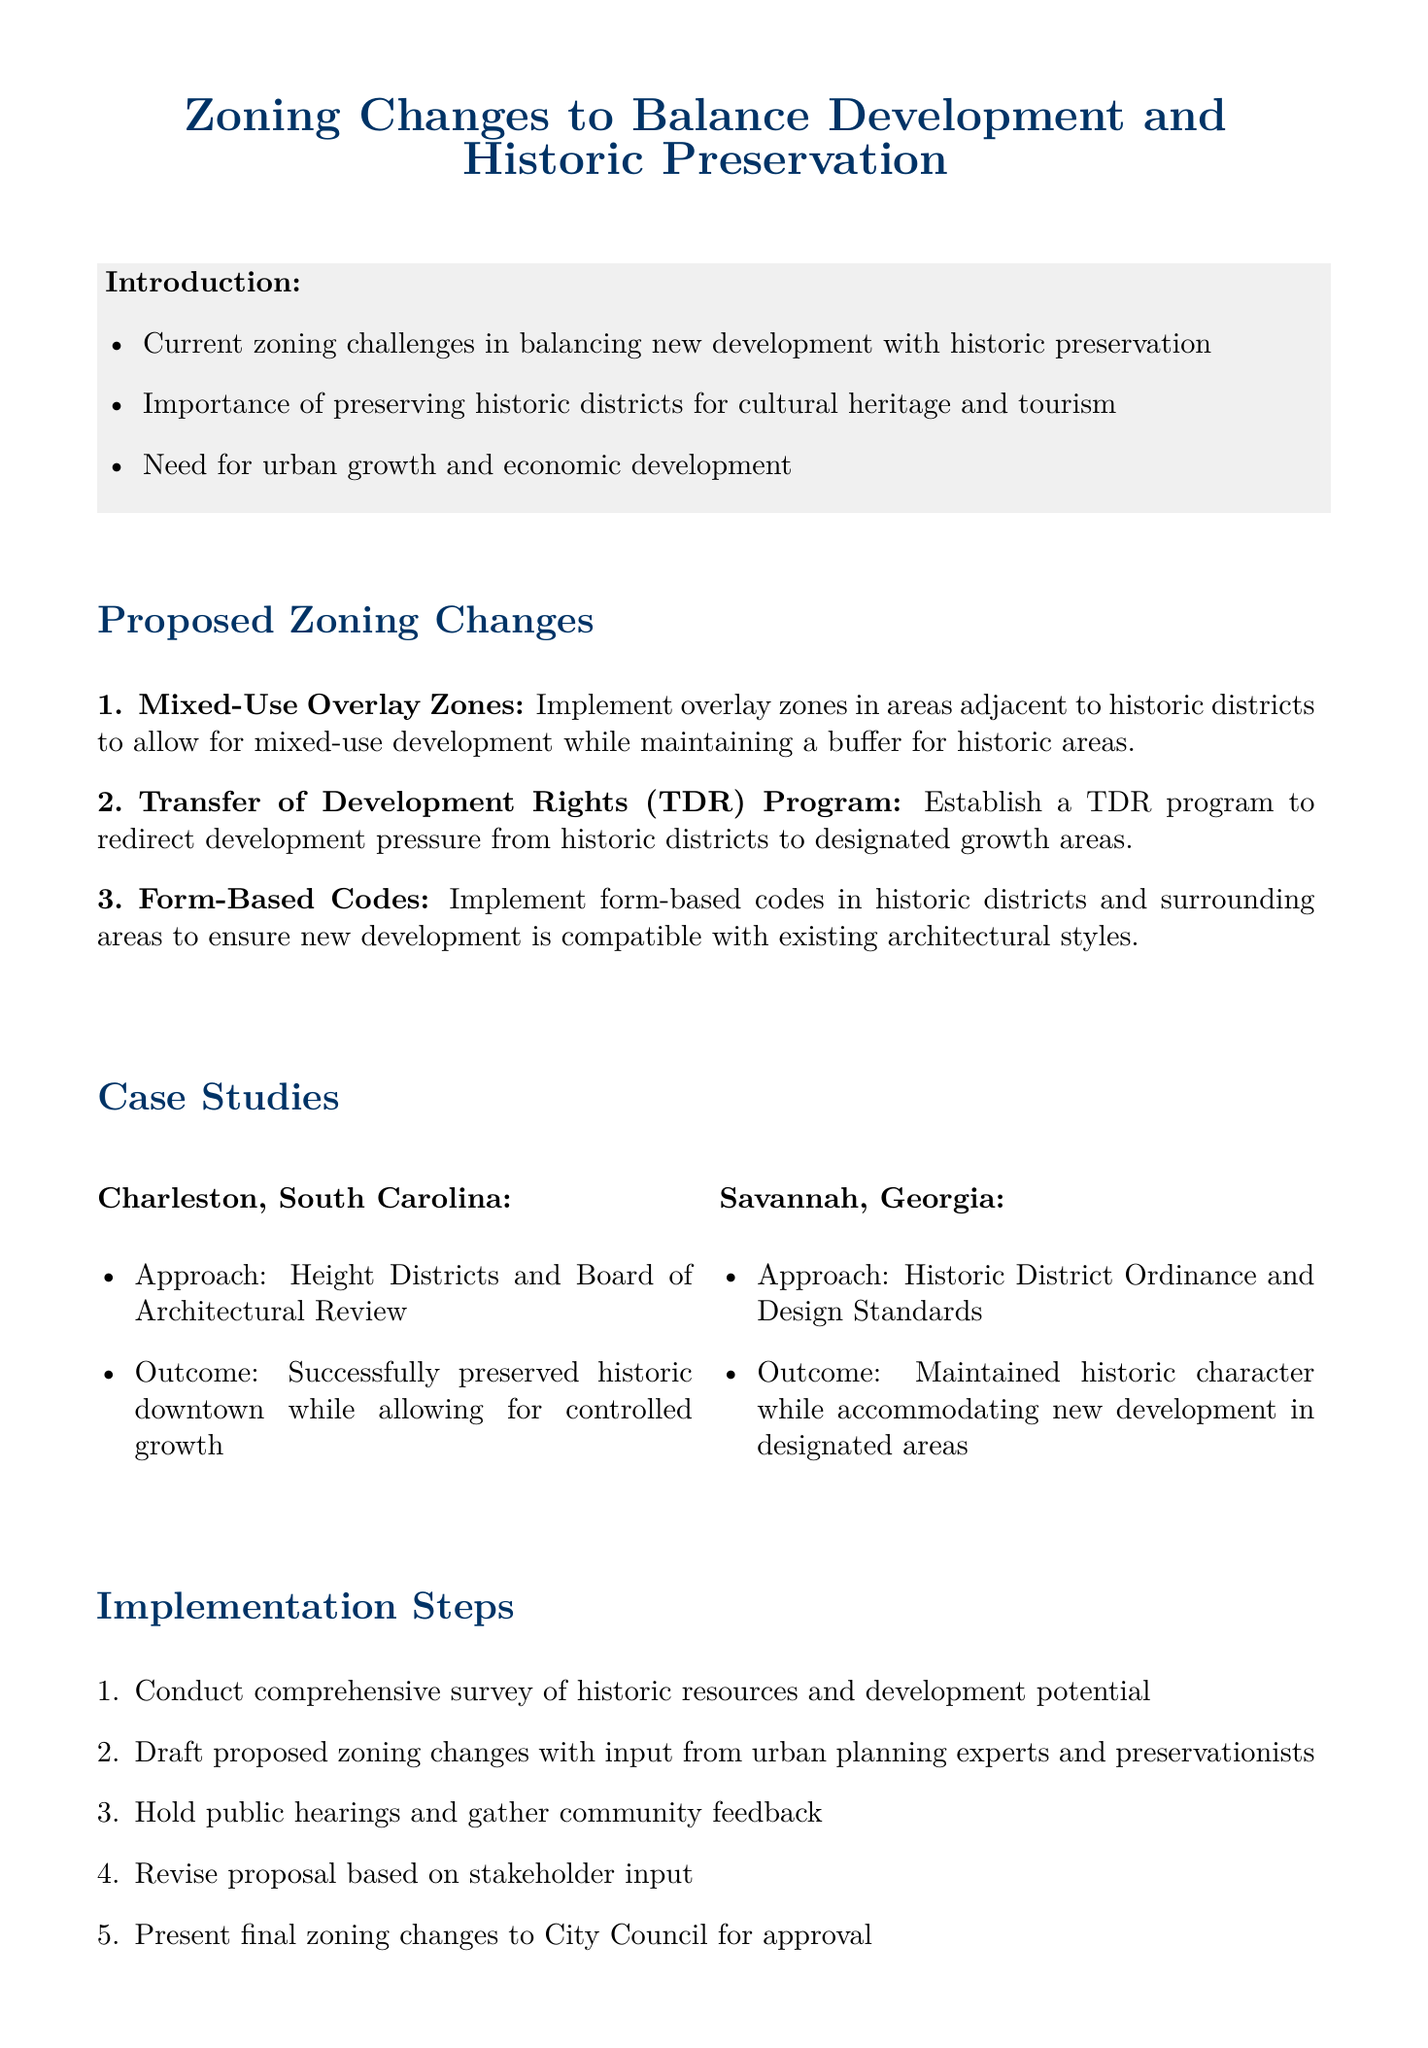What are the proposed zoning changes? The memo lists three proposed zoning changes which are Mixed-Use Overlay Zones, Transfer of Development Rights Program, and Form-Based Codes.
Answer: Mixed-Use Overlay Zones, Transfer of Development Rights (TDR) Program, Form-Based Codes What is the purpose of the Transfer of Development Rights Program? The purpose of the TDR program is established to redirect development pressure from historic districts to designated growth areas, preserving historic properties.
Answer: Redirect development pressure Which city was mentioned as a case study for preserving historic downtown? The memo provides two case studies, and Charleston, South Carolina is specifically mentioned for preserving its historic downtown.
Answer: Charleston, South Carolina What benefit does the Form-Based Codes offer? The Form-Based Codes provide clear guidelines for developers to ensure new development is compatible with existing architectural styles.
Answer: Clear guidelines for developers What step comes after holding public hearings in the implementation process? After holding public hearings, the next step is to revise the proposal based on stakeholder input.
Answer: Revise proposal based on stakeholder input What are stakeholders in this memo concerned about? Stakeholders include local residents, property owners, developers, historic preservation societies, tourism representatives, and local businesses, highlighting diverse concerns in urban development.
Answer: Local residents and property owners What is a potential challenge mentioned in the memo? The memo lists several challenges, one of which is resistance from property owners concerned about restrictions on their properties.
Answer: Resistance from property owners How many case studies are mentioned in the document? The document mentions two case studies which are Charleston, South Carolina and Savannah, Georgia.
Answer: Two 